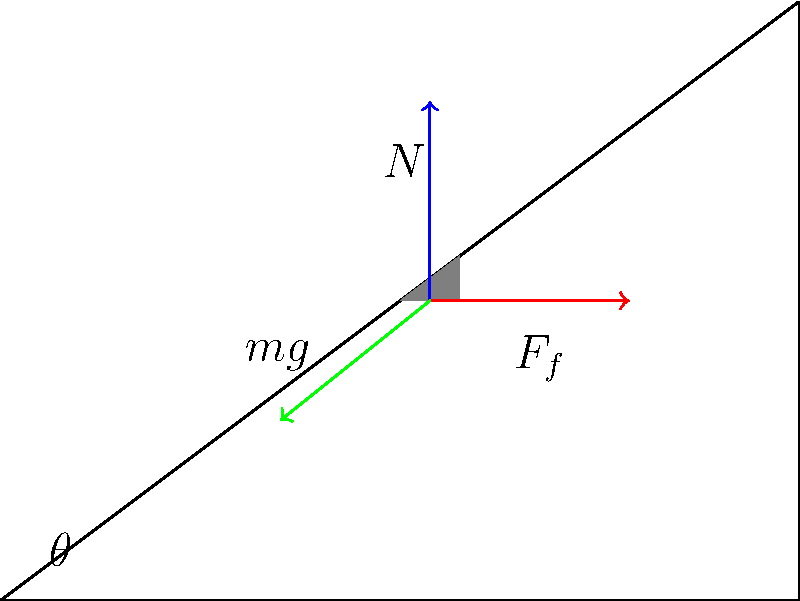In our virtual language learning session, let's discuss physics in the target language. Consider an object resting on an inclined plane at an angle $\theta$ to the horizontal. Identify the forces acting on the object and explain how you would determine the magnitude of the normal force $N$ in terms of the object's mass $m$, gravitational acceleration $g$, and the angle $\theta$. Let's break this down step-by-step:

1) The forces acting on the object are:
   - Weight ($mg$): Always vertically downward
   - Normal force ($N$): Perpendicular to the inclined surface
   - Friction force ($F_f$): Parallel to the surface, opposing potential motion

2) To find the normal force, we need to consider the component of the weight perpendicular to the inclined plane.

3) The weight $mg$ can be resolved into two components:
   - Parallel to the plane: $mg \sin\theta$
   - Perpendicular to the plane: $mg \cos\theta$

4) The normal force $N$ balances the component of weight perpendicular to the plane.

5) Therefore, we can write:
   $N = mg \cos\theta$

6) This equation gives us the magnitude of the normal force in terms of $m$, $g$, and $\theta$.

In the context of our language learning session, we could practice describing this scenario and the forces involved in the target language, reinforcing both physics vocabulary and concepts.
Answer: $N = mg \cos\theta$ 